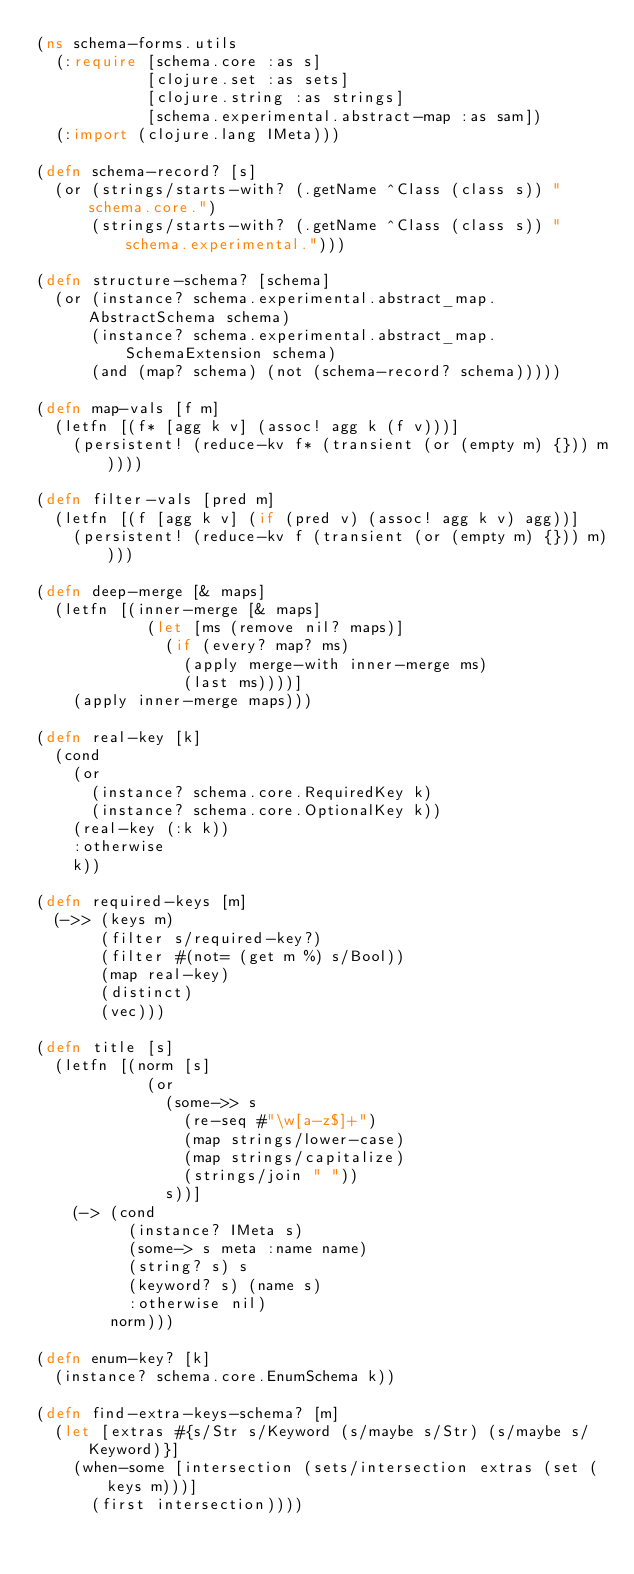<code> <loc_0><loc_0><loc_500><loc_500><_Clojure_>(ns schema-forms.utils
  (:require [schema.core :as s]
            [clojure.set :as sets]
            [clojure.string :as strings]
            [schema.experimental.abstract-map :as sam])
  (:import (clojure.lang IMeta)))

(defn schema-record? [s]
  (or (strings/starts-with? (.getName ^Class (class s)) "schema.core.")
      (strings/starts-with? (.getName ^Class (class s)) "schema.experimental.")))

(defn structure-schema? [schema]
  (or (instance? schema.experimental.abstract_map.AbstractSchema schema)
      (instance? schema.experimental.abstract_map.SchemaExtension schema)
      (and (map? schema) (not (schema-record? schema)))))

(defn map-vals [f m]
  (letfn [(f* [agg k v] (assoc! agg k (f v)))]
    (persistent! (reduce-kv f* (transient (or (empty m) {})) m))))

(defn filter-vals [pred m]
  (letfn [(f [agg k v] (if (pred v) (assoc! agg k v) agg))]
    (persistent! (reduce-kv f (transient (or (empty m) {})) m))))

(defn deep-merge [& maps]
  (letfn [(inner-merge [& maps]
            (let [ms (remove nil? maps)]
              (if (every? map? ms)
                (apply merge-with inner-merge ms)
                (last ms))))]
    (apply inner-merge maps)))

(defn real-key [k]
  (cond
    (or
      (instance? schema.core.RequiredKey k)
      (instance? schema.core.OptionalKey k))
    (real-key (:k k))
    :otherwise
    k))

(defn required-keys [m]
  (->> (keys m)
       (filter s/required-key?)
       (filter #(not= (get m %) s/Bool))
       (map real-key)
       (distinct)
       (vec)))

(defn title [s]
  (letfn [(norm [s]
            (or
              (some->> s
                (re-seq #"\w[a-z$]+")
                (map strings/lower-case)
                (map strings/capitalize)
                (strings/join " "))
              s))]
    (-> (cond
          (instance? IMeta s)
          (some-> s meta :name name)
          (string? s) s
          (keyword? s) (name s)
          :otherwise nil)
        norm)))

(defn enum-key? [k]
  (instance? schema.core.EnumSchema k))

(defn find-extra-keys-schema? [m]
  (let [extras #{s/Str s/Keyword (s/maybe s/Str) (s/maybe s/Keyword)}]
    (when-some [intersection (sets/intersection extras (set (keys m)))]
      (first intersection))))
</code> 